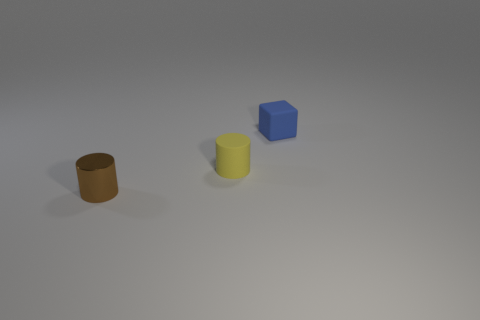Is there another block of the same color as the cube?
Your answer should be compact. No. The block is what color?
Provide a short and direct response. Blue. There is a tiny cylinder behind the small metallic thing; are there any small yellow matte cylinders behind it?
Offer a terse response. No. How many brown metal things are there?
Keep it short and to the point. 1. Do the tiny rubber block and the cylinder right of the brown metallic thing have the same color?
Give a very brief answer. No. Is the number of cyan matte blocks greater than the number of tiny matte cylinders?
Ensure brevity in your answer.  No. Is there any other thing of the same color as the metallic cylinder?
Your answer should be very brief. No. How many other objects are the same size as the blue thing?
Provide a succinct answer. 2. What is the material of the cylinder that is right of the tiny object that is left of the small rubber object that is left of the cube?
Your answer should be compact. Rubber. Are the small brown thing and the object behind the small rubber cylinder made of the same material?
Your response must be concise. No. 